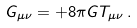Convert formula to latex. <formula><loc_0><loc_0><loc_500><loc_500>G _ { \mu \nu } = + 8 \pi G T _ { \mu \nu } \, .</formula> 